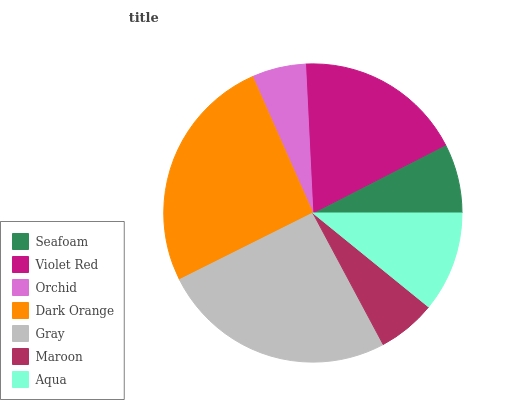Is Orchid the minimum?
Answer yes or no. Yes. Is Dark Orange the maximum?
Answer yes or no. Yes. Is Violet Red the minimum?
Answer yes or no. No. Is Violet Red the maximum?
Answer yes or no. No. Is Violet Red greater than Seafoam?
Answer yes or no. Yes. Is Seafoam less than Violet Red?
Answer yes or no. Yes. Is Seafoam greater than Violet Red?
Answer yes or no. No. Is Violet Red less than Seafoam?
Answer yes or no. No. Is Aqua the high median?
Answer yes or no. Yes. Is Aqua the low median?
Answer yes or no. Yes. Is Maroon the high median?
Answer yes or no. No. Is Maroon the low median?
Answer yes or no. No. 